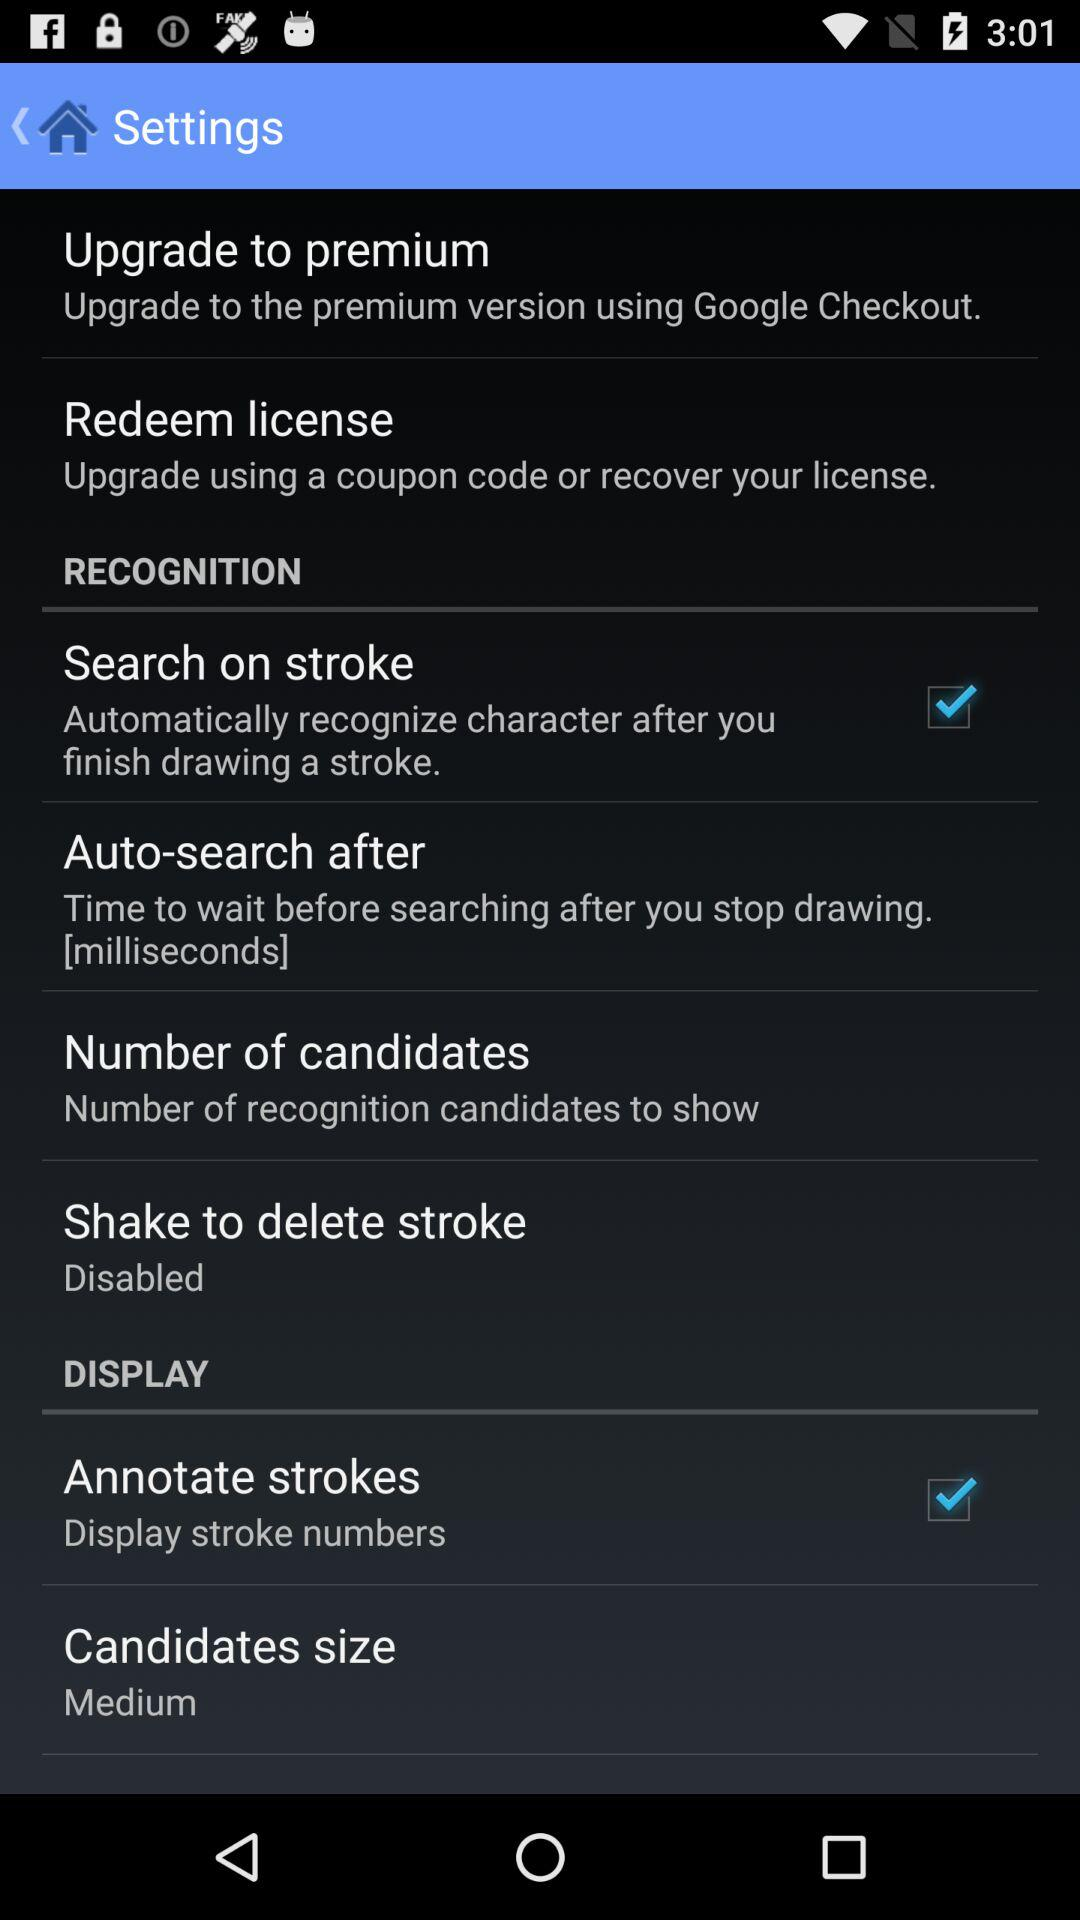What is the setting for the "Annotate strokes" option? The setting for the "Annotate strokes" option is "Display stroke numbers". 